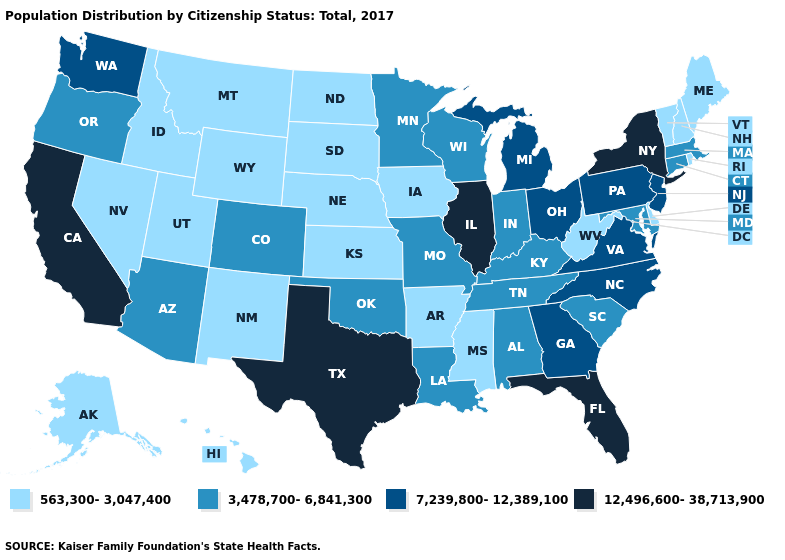Does Idaho have the same value as Kentucky?
Quick response, please. No. Among the states that border Washington , which have the lowest value?
Short answer required. Idaho. How many symbols are there in the legend?
Write a very short answer. 4. Does Georgia have a higher value than New York?
Write a very short answer. No. Does Minnesota have the lowest value in the MidWest?
Short answer required. No. Among the states that border Michigan , does Indiana have the highest value?
Quick response, please. No. What is the lowest value in the USA?
Keep it brief. 563,300-3,047,400. Name the states that have a value in the range 7,239,800-12,389,100?
Write a very short answer. Georgia, Michigan, New Jersey, North Carolina, Ohio, Pennsylvania, Virginia, Washington. Name the states that have a value in the range 7,239,800-12,389,100?
Give a very brief answer. Georgia, Michigan, New Jersey, North Carolina, Ohio, Pennsylvania, Virginia, Washington. What is the value of West Virginia?
Write a very short answer. 563,300-3,047,400. Among the states that border Idaho , which have the lowest value?
Quick response, please. Montana, Nevada, Utah, Wyoming. Does Ohio have the lowest value in the USA?
Quick response, please. No. Is the legend a continuous bar?
Concise answer only. No. Among the states that border California , does Nevada have the lowest value?
Quick response, please. Yes. Name the states that have a value in the range 3,478,700-6,841,300?
Short answer required. Alabama, Arizona, Colorado, Connecticut, Indiana, Kentucky, Louisiana, Maryland, Massachusetts, Minnesota, Missouri, Oklahoma, Oregon, South Carolina, Tennessee, Wisconsin. 